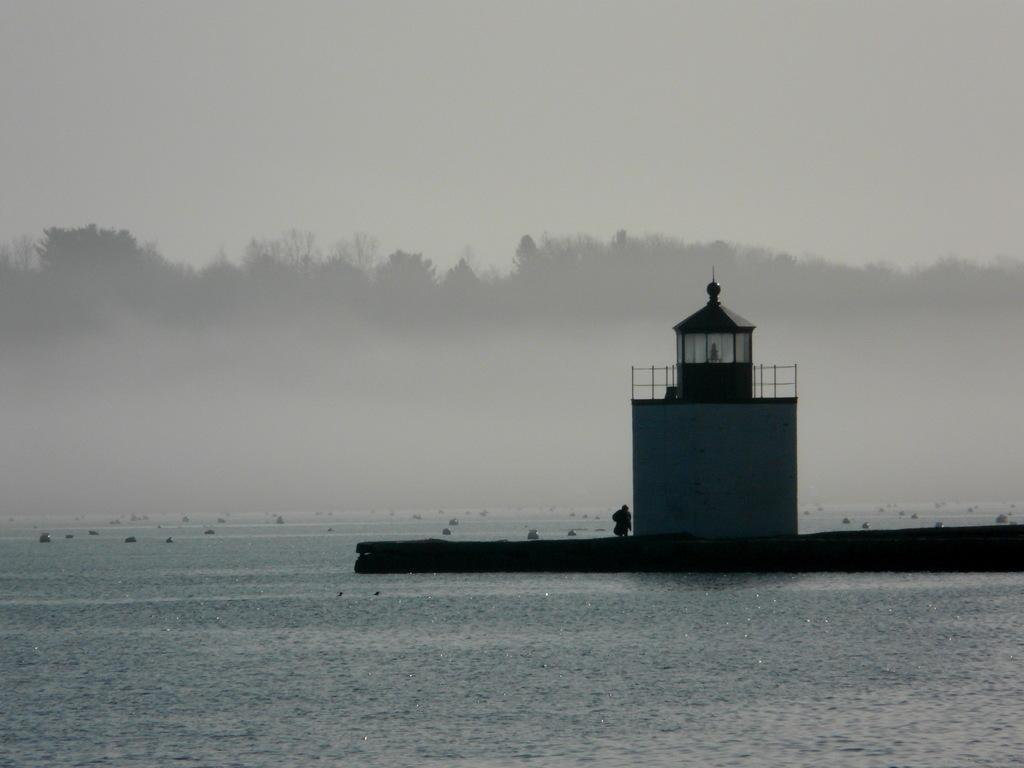What is present in the image that is not solid? There is water in the image. What can be seen in the image that is not a natural element? There is a building in the image. What is the person in the image doing? The facts do not specify what the person is doing. What type of vegetation is present in the image? There are trees in the image. What is visible in the image that is not on the ground? The sky is visible in the image. How would you describe the lighting in the image? The image is described as being a little dark. What type of cream is being used to paint the ship in the image? There is no ship or cream present in the image. What question is the person asking in the image? The facts do not specify if the person is asking a question or not. 